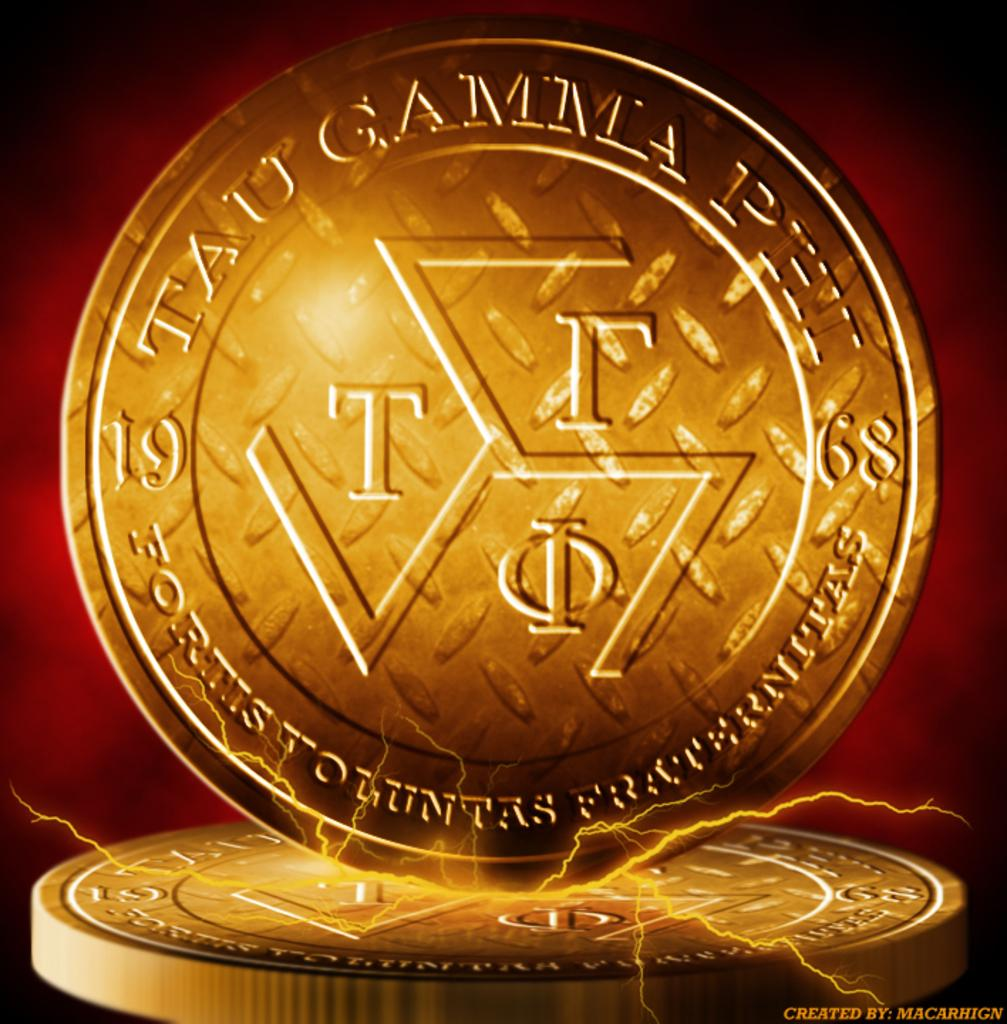Provide a one-sentence caption for the provided image. A graphic of a coin with Greek lettering sits on another coin. 